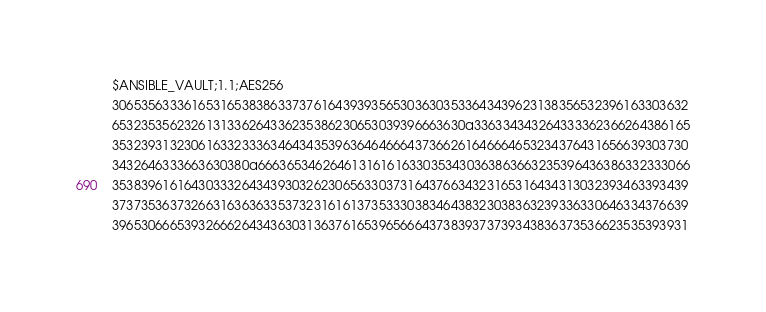Convert code to text. <code><loc_0><loc_0><loc_500><loc_500><_YAML_>$ANSIBLE_VAULT;1.1;AES256
30653563336165316538386337376164393935653036303533643439623138356532396163303632
6532353562326131336264336235386230653039396663630a336334343264333362366264386165
35323931323061633233363464343539636464666437366261646664653234376431656639303730
3432646333663630380a666365346264613161616330353430363863663235396436386332333066
35383961616430333264343930326230656330373164376634323165316434313032393463393439
37373536373266316363633537323161613735333038346438323038363239336330646334376639
39653066653932666264343630313637616539656664373839373739343836373536623535393931</code> 